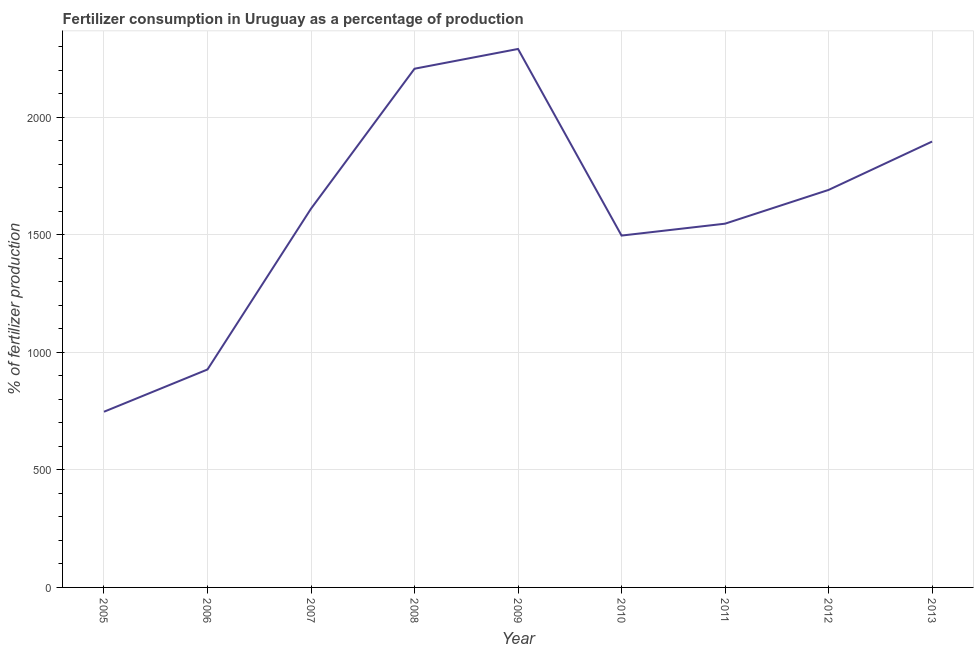What is the amount of fertilizer consumption in 2010?
Keep it short and to the point. 1496.86. Across all years, what is the maximum amount of fertilizer consumption?
Ensure brevity in your answer.  2290.74. Across all years, what is the minimum amount of fertilizer consumption?
Keep it short and to the point. 747.37. What is the sum of the amount of fertilizer consumption?
Ensure brevity in your answer.  1.44e+04. What is the difference between the amount of fertilizer consumption in 2006 and 2009?
Ensure brevity in your answer.  -1363.59. What is the average amount of fertilizer consumption per year?
Give a very brief answer. 1601.72. What is the median amount of fertilizer consumption?
Keep it short and to the point. 1611.26. In how many years, is the amount of fertilizer consumption greater than 1100 %?
Offer a terse response. 7. Do a majority of the years between 2006 and 2011 (inclusive) have amount of fertilizer consumption greater than 2100 %?
Offer a very short reply. No. What is the ratio of the amount of fertilizer consumption in 2010 to that in 2012?
Your response must be concise. 0.89. Is the difference between the amount of fertilizer consumption in 2005 and 2010 greater than the difference between any two years?
Keep it short and to the point. No. What is the difference between the highest and the second highest amount of fertilizer consumption?
Offer a very short reply. 84.03. What is the difference between the highest and the lowest amount of fertilizer consumption?
Keep it short and to the point. 1543.37. In how many years, is the amount of fertilizer consumption greater than the average amount of fertilizer consumption taken over all years?
Give a very brief answer. 5. Does the amount of fertilizer consumption monotonically increase over the years?
Offer a very short reply. No. How many lines are there?
Your answer should be very brief. 1. How many years are there in the graph?
Make the answer very short. 9. What is the difference between two consecutive major ticks on the Y-axis?
Provide a short and direct response. 500. Are the values on the major ticks of Y-axis written in scientific E-notation?
Make the answer very short. No. What is the title of the graph?
Ensure brevity in your answer.  Fertilizer consumption in Uruguay as a percentage of production. What is the label or title of the X-axis?
Your response must be concise. Year. What is the label or title of the Y-axis?
Ensure brevity in your answer.  % of fertilizer production. What is the % of fertilizer production of 2005?
Your answer should be compact. 747.37. What is the % of fertilizer production of 2006?
Make the answer very short. 927.16. What is the % of fertilizer production in 2007?
Provide a short and direct response. 1611.26. What is the % of fertilizer production in 2008?
Keep it short and to the point. 2206.71. What is the % of fertilizer production in 2009?
Give a very brief answer. 2290.74. What is the % of fertilizer production in 2010?
Ensure brevity in your answer.  1496.86. What is the % of fertilizer production of 2011?
Give a very brief answer. 1547.47. What is the % of fertilizer production of 2012?
Provide a short and direct response. 1691.07. What is the % of fertilizer production of 2013?
Your response must be concise. 1896.87. What is the difference between the % of fertilizer production in 2005 and 2006?
Make the answer very short. -179.79. What is the difference between the % of fertilizer production in 2005 and 2007?
Your answer should be very brief. -863.89. What is the difference between the % of fertilizer production in 2005 and 2008?
Give a very brief answer. -1459.34. What is the difference between the % of fertilizer production in 2005 and 2009?
Provide a succinct answer. -1543.37. What is the difference between the % of fertilizer production in 2005 and 2010?
Keep it short and to the point. -749.49. What is the difference between the % of fertilizer production in 2005 and 2011?
Your answer should be compact. -800.1. What is the difference between the % of fertilizer production in 2005 and 2012?
Your response must be concise. -943.69. What is the difference between the % of fertilizer production in 2005 and 2013?
Offer a very short reply. -1149.49. What is the difference between the % of fertilizer production in 2006 and 2007?
Give a very brief answer. -684.1. What is the difference between the % of fertilizer production in 2006 and 2008?
Make the answer very short. -1279.56. What is the difference between the % of fertilizer production in 2006 and 2009?
Your answer should be compact. -1363.59. What is the difference between the % of fertilizer production in 2006 and 2010?
Your answer should be compact. -569.7. What is the difference between the % of fertilizer production in 2006 and 2011?
Your answer should be compact. -620.32. What is the difference between the % of fertilizer production in 2006 and 2012?
Provide a succinct answer. -763.91. What is the difference between the % of fertilizer production in 2006 and 2013?
Your response must be concise. -969.71. What is the difference between the % of fertilizer production in 2007 and 2008?
Provide a succinct answer. -595.45. What is the difference between the % of fertilizer production in 2007 and 2009?
Keep it short and to the point. -679.48. What is the difference between the % of fertilizer production in 2007 and 2010?
Your answer should be very brief. 114.4. What is the difference between the % of fertilizer production in 2007 and 2011?
Offer a terse response. 63.78. What is the difference between the % of fertilizer production in 2007 and 2012?
Your answer should be compact. -79.81. What is the difference between the % of fertilizer production in 2007 and 2013?
Make the answer very short. -285.61. What is the difference between the % of fertilizer production in 2008 and 2009?
Provide a succinct answer. -84.03. What is the difference between the % of fertilizer production in 2008 and 2010?
Offer a very short reply. 709.85. What is the difference between the % of fertilizer production in 2008 and 2011?
Provide a succinct answer. 659.24. What is the difference between the % of fertilizer production in 2008 and 2012?
Give a very brief answer. 515.65. What is the difference between the % of fertilizer production in 2008 and 2013?
Ensure brevity in your answer.  309.85. What is the difference between the % of fertilizer production in 2009 and 2010?
Make the answer very short. 793.89. What is the difference between the % of fertilizer production in 2009 and 2011?
Offer a terse response. 743.27. What is the difference between the % of fertilizer production in 2009 and 2012?
Offer a very short reply. 599.68. What is the difference between the % of fertilizer production in 2009 and 2013?
Make the answer very short. 393.88. What is the difference between the % of fertilizer production in 2010 and 2011?
Give a very brief answer. -50.62. What is the difference between the % of fertilizer production in 2010 and 2012?
Your answer should be very brief. -194.21. What is the difference between the % of fertilizer production in 2010 and 2013?
Your answer should be compact. -400.01. What is the difference between the % of fertilizer production in 2011 and 2012?
Give a very brief answer. -143.59. What is the difference between the % of fertilizer production in 2011 and 2013?
Provide a succinct answer. -349.39. What is the difference between the % of fertilizer production in 2012 and 2013?
Make the answer very short. -205.8. What is the ratio of the % of fertilizer production in 2005 to that in 2006?
Ensure brevity in your answer.  0.81. What is the ratio of the % of fertilizer production in 2005 to that in 2007?
Give a very brief answer. 0.46. What is the ratio of the % of fertilizer production in 2005 to that in 2008?
Your answer should be very brief. 0.34. What is the ratio of the % of fertilizer production in 2005 to that in 2009?
Your answer should be very brief. 0.33. What is the ratio of the % of fertilizer production in 2005 to that in 2010?
Provide a short and direct response. 0.5. What is the ratio of the % of fertilizer production in 2005 to that in 2011?
Provide a short and direct response. 0.48. What is the ratio of the % of fertilizer production in 2005 to that in 2012?
Your response must be concise. 0.44. What is the ratio of the % of fertilizer production in 2005 to that in 2013?
Ensure brevity in your answer.  0.39. What is the ratio of the % of fertilizer production in 2006 to that in 2007?
Offer a very short reply. 0.57. What is the ratio of the % of fertilizer production in 2006 to that in 2008?
Your response must be concise. 0.42. What is the ratio of the % of fertilizer production in 2006 to that in 2009?
Offer a terse response. 0.41. What is the ratio of the % of fertilizer production in 2006 to that in 2010?
Make the answer very short. 0.62. What is the ratio of the % of fertilizer production in 2006 to that in 2011?
Keep it short and to the point. 0.6. What is the ratio of the % of fertilizer production in 2006 to that in 2012?
Ensure brevity in your answer.  0.55. What is the ratio of the % of fertilizer production in 2006 to that in 2013?
Your answer should be very brief. 0.49. What is the ratio of the % of fertilizer production in 2007 to that in 2008?
Your answer should be compact. 0.73. What is the ratio of the % of fertilizer production in 2007 to that in 2009?
Keep it short and to the point. 0.7. What is the ratio of the % of fertilizer production in 2007 to that in 2010?
Your answer should be compact. 1.08. What is the ratio of the % of fertilizer production in 2007 to that in 2011?
Offer a terse response. 1.04. What is the ratio of the % of fertilizer production in 2007 to that in 2012?
Provide a succinct answer. 0.95. What is the ratio of the % of fertilizer production in 2007 to that in 2013?
Provide a succinct answer. 0.85. What is the ratio of the % of fertilizer production in 2008 to that in 2010?
Offer a very short reply. 1.47. What is the ratio of the % of fertilizer production in 2008 to that in 2011?
Keep it short and to the point. 1.43. What is the ratio of the % of fertilizer production in 2008 to that in 2012?
Your response must be concise. 1.3. What is the ratio of the % of fertilizer production in 2008 to that in 2013?
Keep it short and to the point. 1.16. What is the ratio of the % of fertilizer production in 2009 to that in 2010?
Provide a short and direct response. 1.53. What is the ratio of the % of fertilizer production in 2009 to that in 2011?
Provide a short and direct response. 1.48. What is the ratio of the % of fertilizer production in 2009 to that in 2012?
Ensure brevity in your answer.  1.35. What is the ratio of the % of fertilizer production in 2009 to that in 2013?
Your answer should be compact. 1.21. What is the ratio of the % of fertilizer production in 2010 to that in 2011?
Make the answer very short. 0.97. What is the ratio of the % of fertilizer production in 2010 to that in 2012?
Keep it short and to the point. 0.89. What is the ratio of the % of fertilizer production in 2010 to that in 2013?
Offer a very short reply. 0.79. What is the ratio of the % of fertilizer production in 2011 to that in 2012?
Keep it short and to the point. 0.92. What is the ratio of the % of fertilizer production in 2011 to that in 2013?
Provide a succinct answer. 0.82. What is the ratio of the % of fertilizer production in 2012 to that in 2013?
Make the answer very short. 0.89. 